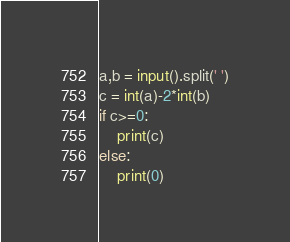Convert code to text. <code><loc_0><loc_0><loc_500><loc_500><_Python_>a,b = input().split(' ')
c = int(a)-2*int(b)
if c>=0:
    print(c)
else:
    print(0)
</code> 